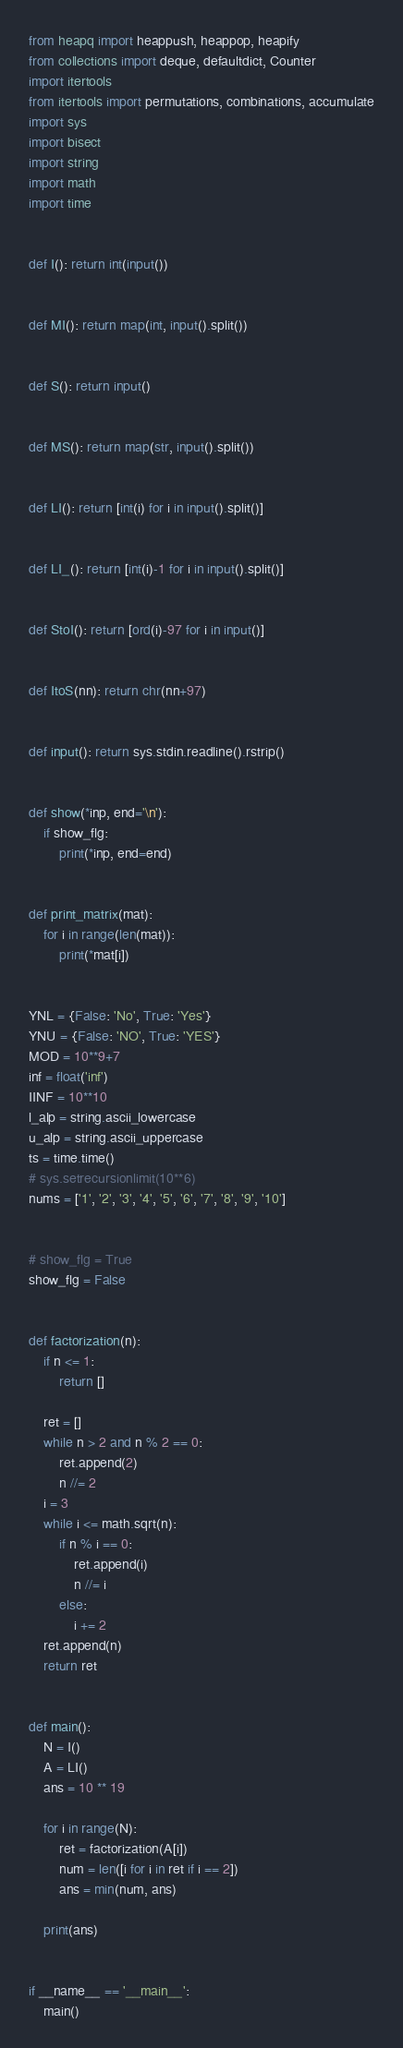<code> <loc_0><loc_0><loc_500><loc_500><_Python_>from heapq import heappush, heappop, heapify
from collections import deque, defaultdict, Counter
import itertools
from itertools import permutations, combinations, accumulate
import sys
import bisect
import string
import math
import time


def I(): return int(input())


def MI(): return map(int, input().split())


def S(): return input()


def MS(): return map(str, input().split())


def LI(): return [int(i) for i in input().split()]


def LI_(): return [int(i)-1 for i in input().split()]


def StoI(): return [ord(i)-97 for i in input()]


def ItoS(nn): return chr(nn+97)


def input(): return sys.stdin.readline().rstrip()


def show(*inp, end='\n'):
    if show_flg:
        print(*inp, end=end)


def print_matrix(mat):
    for i in range(len(mat)):
        print(*mat[i])


YNL = {False: 'No', True: 'Yes'}
YNU = {False: 'NO', True: 'YES'}
MOD = 10**9+7
inf = float('inf')
IINF = 10**10
l_alp = string.ascii_lowercase
u_alp = string.ascii_uppercase
ts = time.time()
# sys.setrecursionlimit(10**6)
nums = ['1', '2', '3', '4', '5', '6', '7', '8', '9', '10']


# show_flg = True
show_flg = False


def factorization(n):
    if n <= 1:
        return []

    ret = []
    while n > 2 and n % 2 == 0:
        ret.append(2)
        n //= 2
    i = 3
    while i <= math.sqrt(n):
        if n % i == 0:
            ret.append(i)
            n //= i
        else:
            i += 2
    ret.append(n)
    return ret


def main():
    N = I()
    A = LI()
    ans = 10 ** 19

    for i in range(N):
        ret = factorization(A[i])
        num = len([i for i in ret if i == 2])
        ans = min(num, ans)

    print(ans)


if __name__ == '__main__':
    main()
</code> 